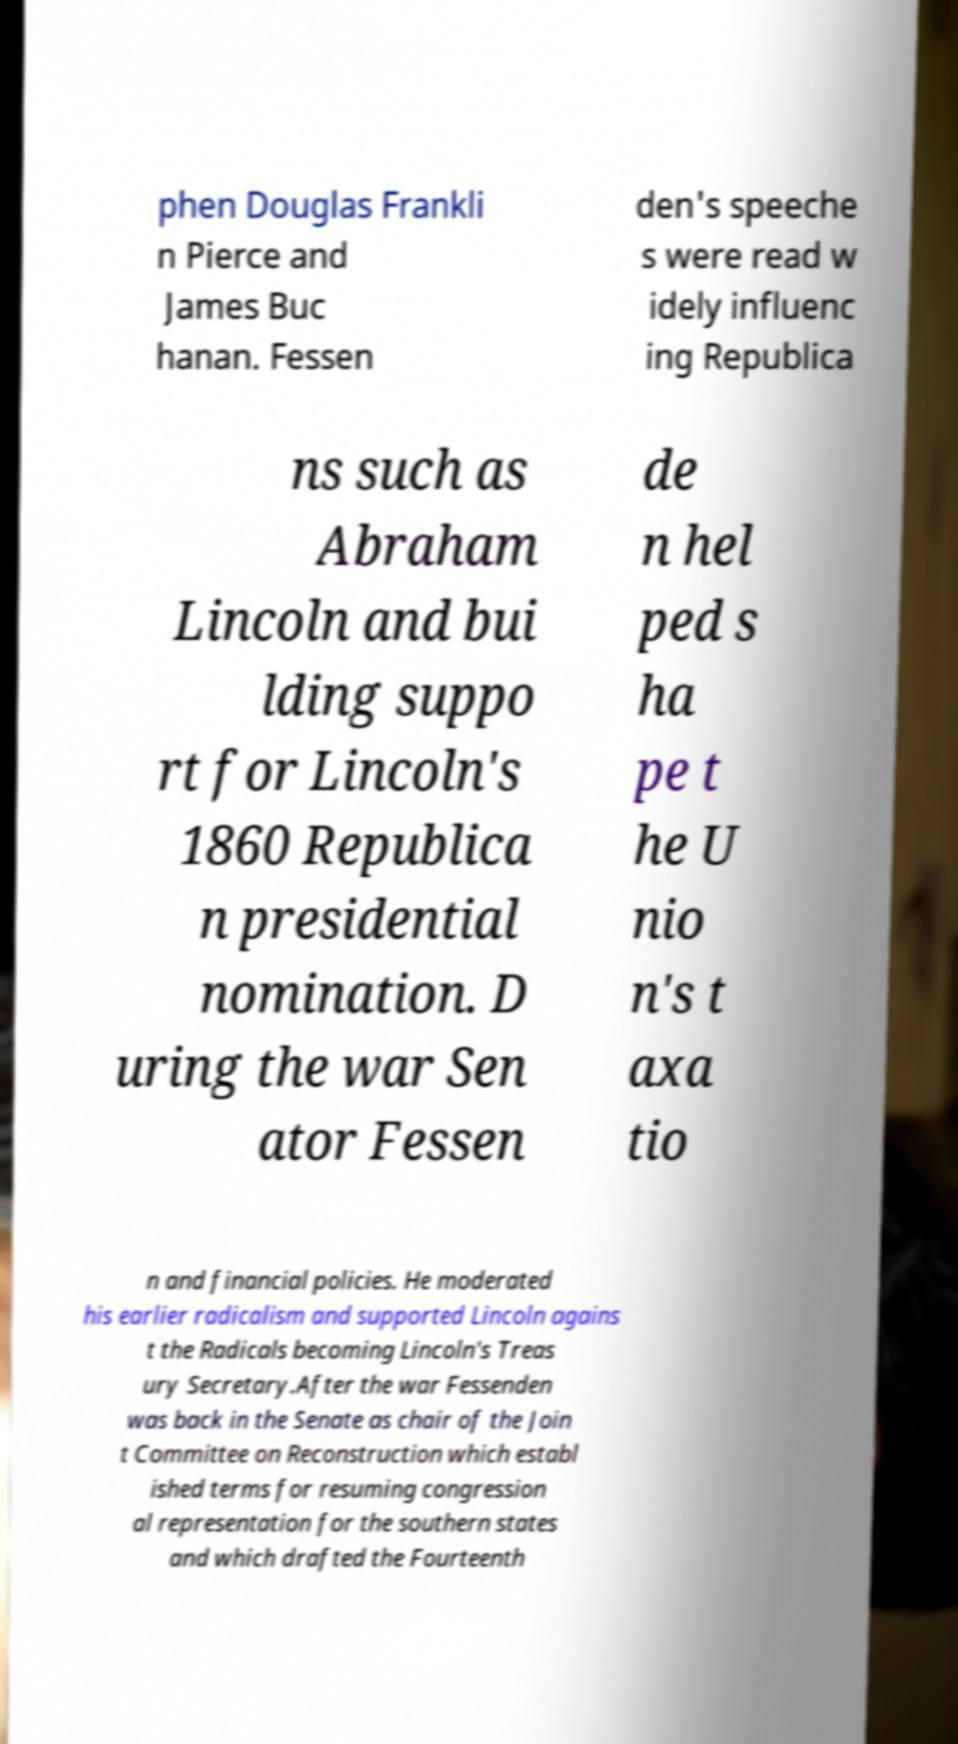For documentation purposes, I need the text within this image transcribed. Could you provide that? phen Douglas Frankli n Pierce and James Buc hanan. Fessen den's speeche s were read w idely influenc ing Republica ns such as Abraham Lincoln and bui lding suppo rt for Lincoln's 1860 Republica n presidential nomination. D uring the war Sen ator Fessen de n hel ped s ha pe t he U nio n's t axa tio n and financial policies. He moderated his earlier radicalism and supported Lincoln agains t the Radicals becoming Lincoln's Treas ury Secretary.After the war Fessenden was back in the Senate as chair of the Join t Committee on Reconstruction which establ ished terms for resuming congression al representation for the southern states and which drafted the Fourteenth 